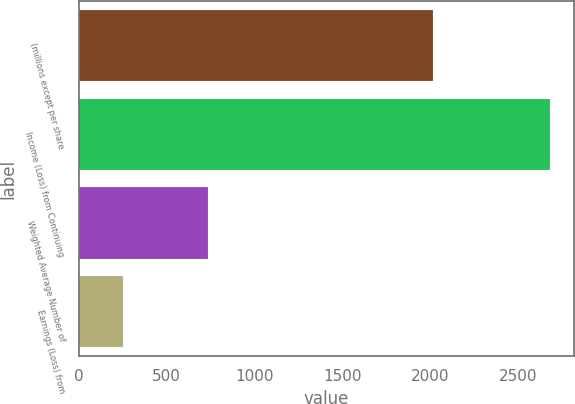Convert chart. <chart><loc_0><loc_0><loc_500><loc_500><bar_chart><fcel>(millions except per share<fcel>Income (Loss) from Continuing<fcel>Weighted Average Number of<fcel>Earnings (Loss) from<nl><fcel>2015<fcel>2684.49<fcel>736.54<fcel>249.56<nl></chart> 